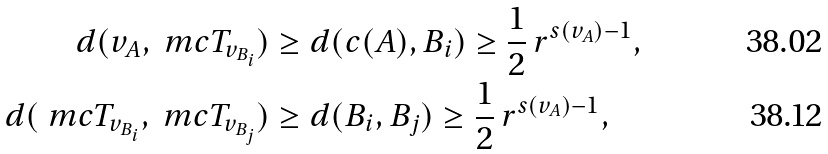<formula> <loc_0><loc_0><loc_500><loc_500>d ( v _ { A } , \ m c T _ { v _ { B _ { i } } } ) & \geq d ( c ( A ) , B _ { i } ) \geq \frac { 1 } { 2 } \, r ^ { s ( v _ { A } ) - 1 } , \\ d ( \ m c T _ { v _ { B _ { i } } } , \ m c T _ { v _ { B _ { j } } } ) & \geq d ( B _ { i } , B _ { j } ) \geq \frac { 1 } { 2 } \, r ^ { s ( v _ { A } ) - 1 } ,</formula> 